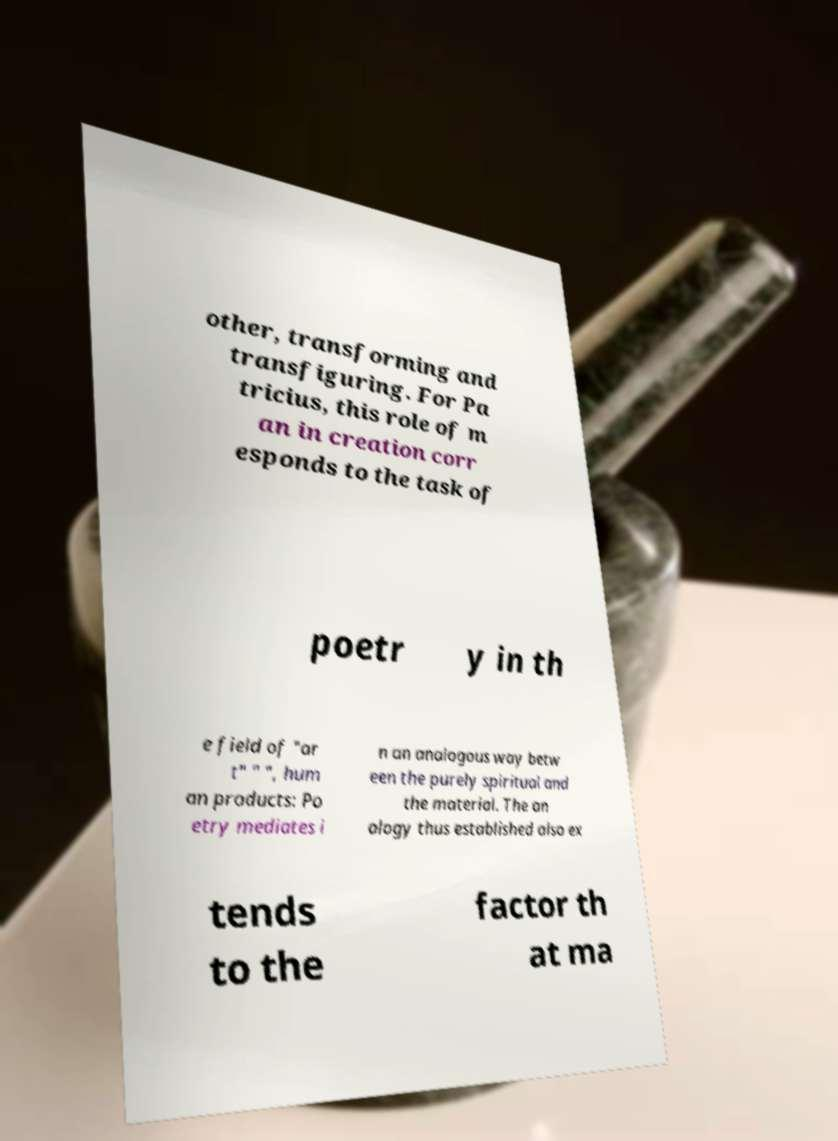Please read and relay the text visible in this image. What does it say? other, transforming and transfiguring. For Pa tricius, this role of m an in creation corr esponds to the task of poetr y in th e field of "ar t" " ", hum an products: Po etry mediates i n an analogous way betw een the purely spiritual and the material. The an alogy thus established also ex tends to the factor th at ma 